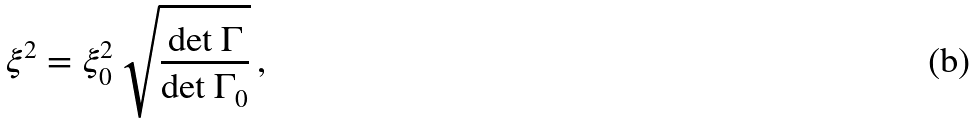Convert formula to latex. <formula><loc_0><loc_0><loc_500><loc_500>\xi ^ { 2 } = \xi ^ { 2 } _ { 0 } \, \sqrt { \frac { \det \Gamma } { \det \Gamma _ { 0 } } } \, ,</formula> 